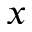Convert formula to latex. <formula><loc_0><loc_0><loc_500><loc_500>x</formula> 